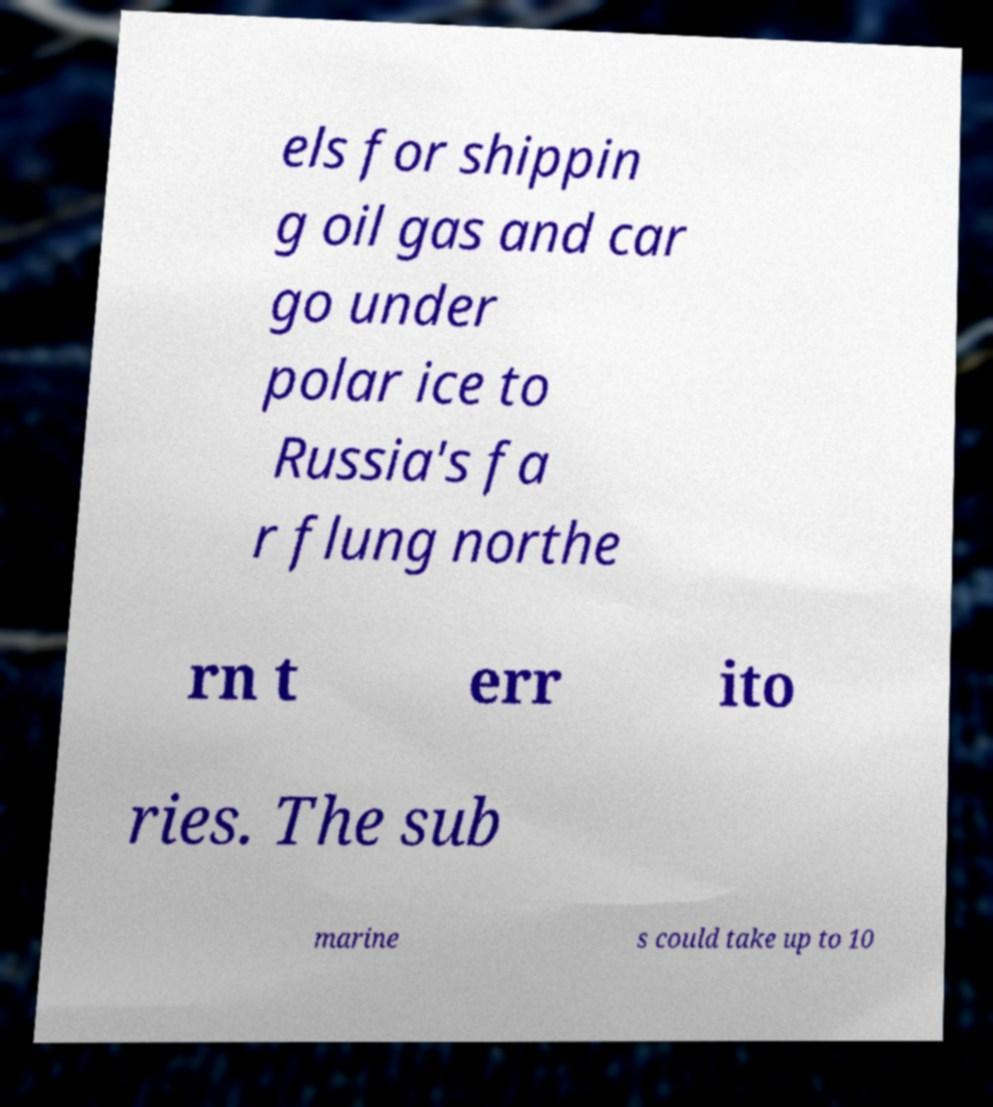There's text embedded in this image that I need extracted. Can you transcribe it verbatim? els for shippin g oil gas and car go under polar ice to Russia's fa r flung northe rn t err ito ries. The sub marine s could take up to 10 